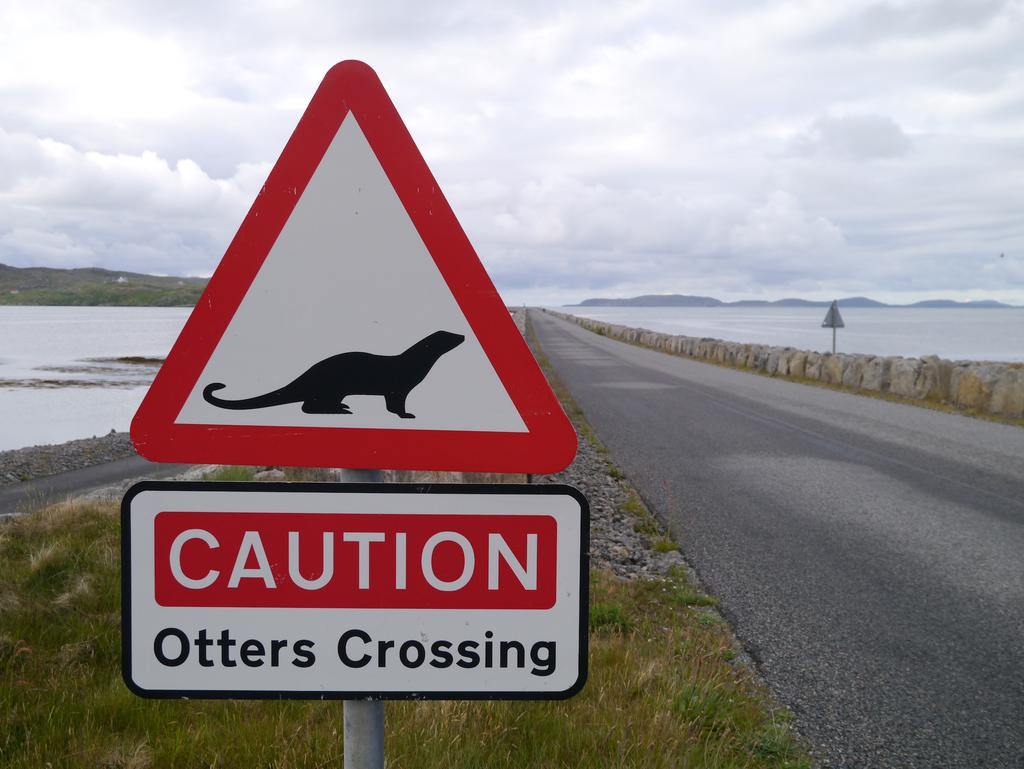<image>
Describe the image concisely. Red and white sign that says CAUTION Otters Crossing. 